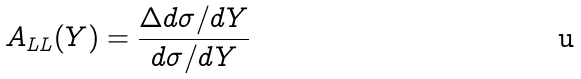Convert formula to latex. <formula><loc_0><loc_0><loc_500><loc_500>A _ { L L } ( Y ) = \frac { \Delta d \sigma / d Y } { d \sigma / d Y }</formula> 